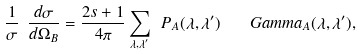<formula> <loc_0><loc_0><loc_500><loc_500>\frac { 1 } { \sigma } \ \frac { d \sigma } { d \Omega _ { B } } = \frac { 2 s + 1 } { 4 \pi } \sum _ { \lambda , \lambda ^ { \prime } } \ P _ { A } ( \lambda , \lambda ^ { \prime } ) \quad G a m m a _ { A } ( \lambda , \lambda ^ { \prime } ) ,</formula> 